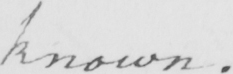Please transcribe the handwritten text in this image. known . 